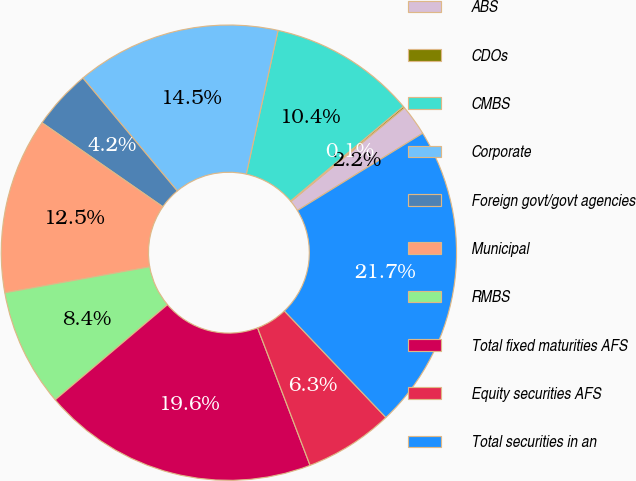Convert chart. <chart><loc_0><loc_0><loc_500><loc_500><pie_chart><fcel>ABS<fcel>CDOs<fcel>CMBS<fcel>Corporate<fcel>Foreign govt/govt agencies<fcel>Municipal<fcel>RMBS<fcel>Total fixed maturities AFS<fcel>Equity securities AFS<fcel>Total securities in an<nl><fcel>2.19%<fcel>0.13%<fcel>10.43%<fcel>14.55%<fcel>4.25%<fcel>12.49%<fcel>8.37%<fcel>19.62%<fcel>6.31%<fcel>21.68%<nl></chart> 